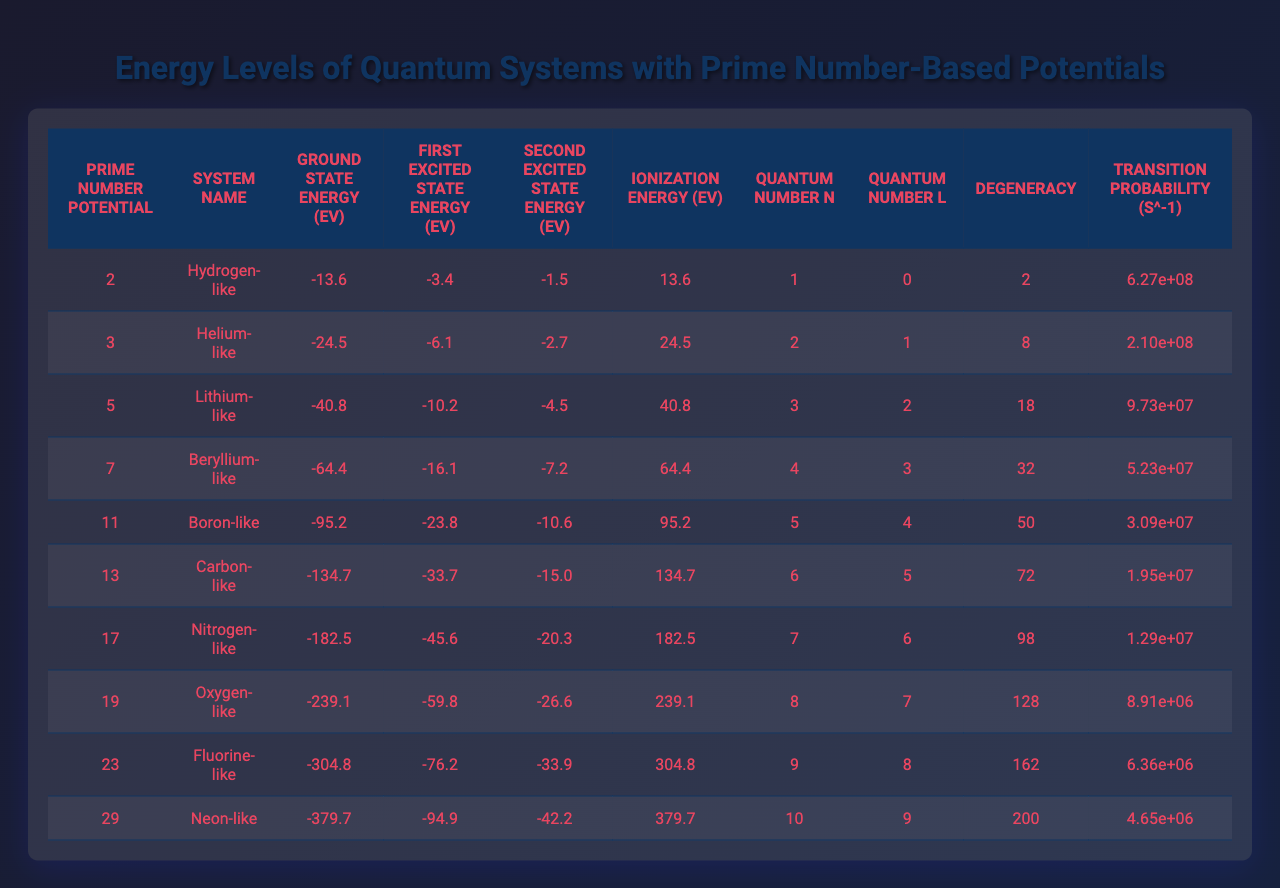What is the ground state energy of the Hydrogen-like system? By looking at the "Ground State Energy (eV)" column corresponding to "Hydrogen-like" in the "System Name" column, we find that the value is -13.6 eV.
Answer: -13.6 eV What is the degeneracy of the Fluorine-like system? The degeneracy is found in the "Degeneracy" column next to the "Fluorine-like" system in the "System Name" column, and is equal to 162.
Answer: 162 What is the ionization energy of the Carbon-like system? The "Ionization Energy (eV)" column for the "Carbon-like" system shows a value of 134.7 eV.
Answer: 134.7 eV Is the Second Excited State Energy of the Nitrogen-like system less than -20 eV? Comparing the value in the "Second Excited State Energy (eV)" for "Nitrogen-like," which is -20.3 eV, shows that it is indeed less than -20 eV.
Answer: Yes What is the average Ground State Energy across all systems listed? To find the average, we add all the ground state energies: -13.6 + -24.5 + -40.8 + -64.4 + -95.2 + -134.7 + -182.5 + -239.1 + -304.8 + -379.7 = -1283.5 eV. There are 10 systems, so the average is -1283.5 eV / 10 = -128.35 eV.
Answer: -128.35 eV What is the transition probability for the Beryllium-like system? By checking the "Transition Probability (s^-1)" column next to "Beryllium-like" in the "System Name" column, the value is 5.23e7 s^-1.
Answer: 5.23e7 s^-1 Does the Ionization Energy increase with the Prime Number Potential? Observing the "Ionization Energy" relative to "Prime Number Potential" shows a direct correlation where both values increase together across the table.
Answer: Yes What is the difference in Ground State Energy between the Lithium-like and Neon-like systems? The Ground State Energy for Lithium-like is -40.8 eV and for Neon-like is -379.7 eV. The difference is -40.8 - (-379.7) = 338.9 eV.
Answer: 338.9 eV Find the system with the highest ionization energy and state its value. Scanning the "Ionization Energy (eV)" column reveals that Neon-like has the highest value of 379.7 eV.
Answer: 379.7 eV What is the relationship between Quantum Number n and Transition Probability? The table demonstrates that as Quantum Number n increases, the Transition Probability generally decreases, indicating an inverse relationship.
Answer: Inverse relationship 